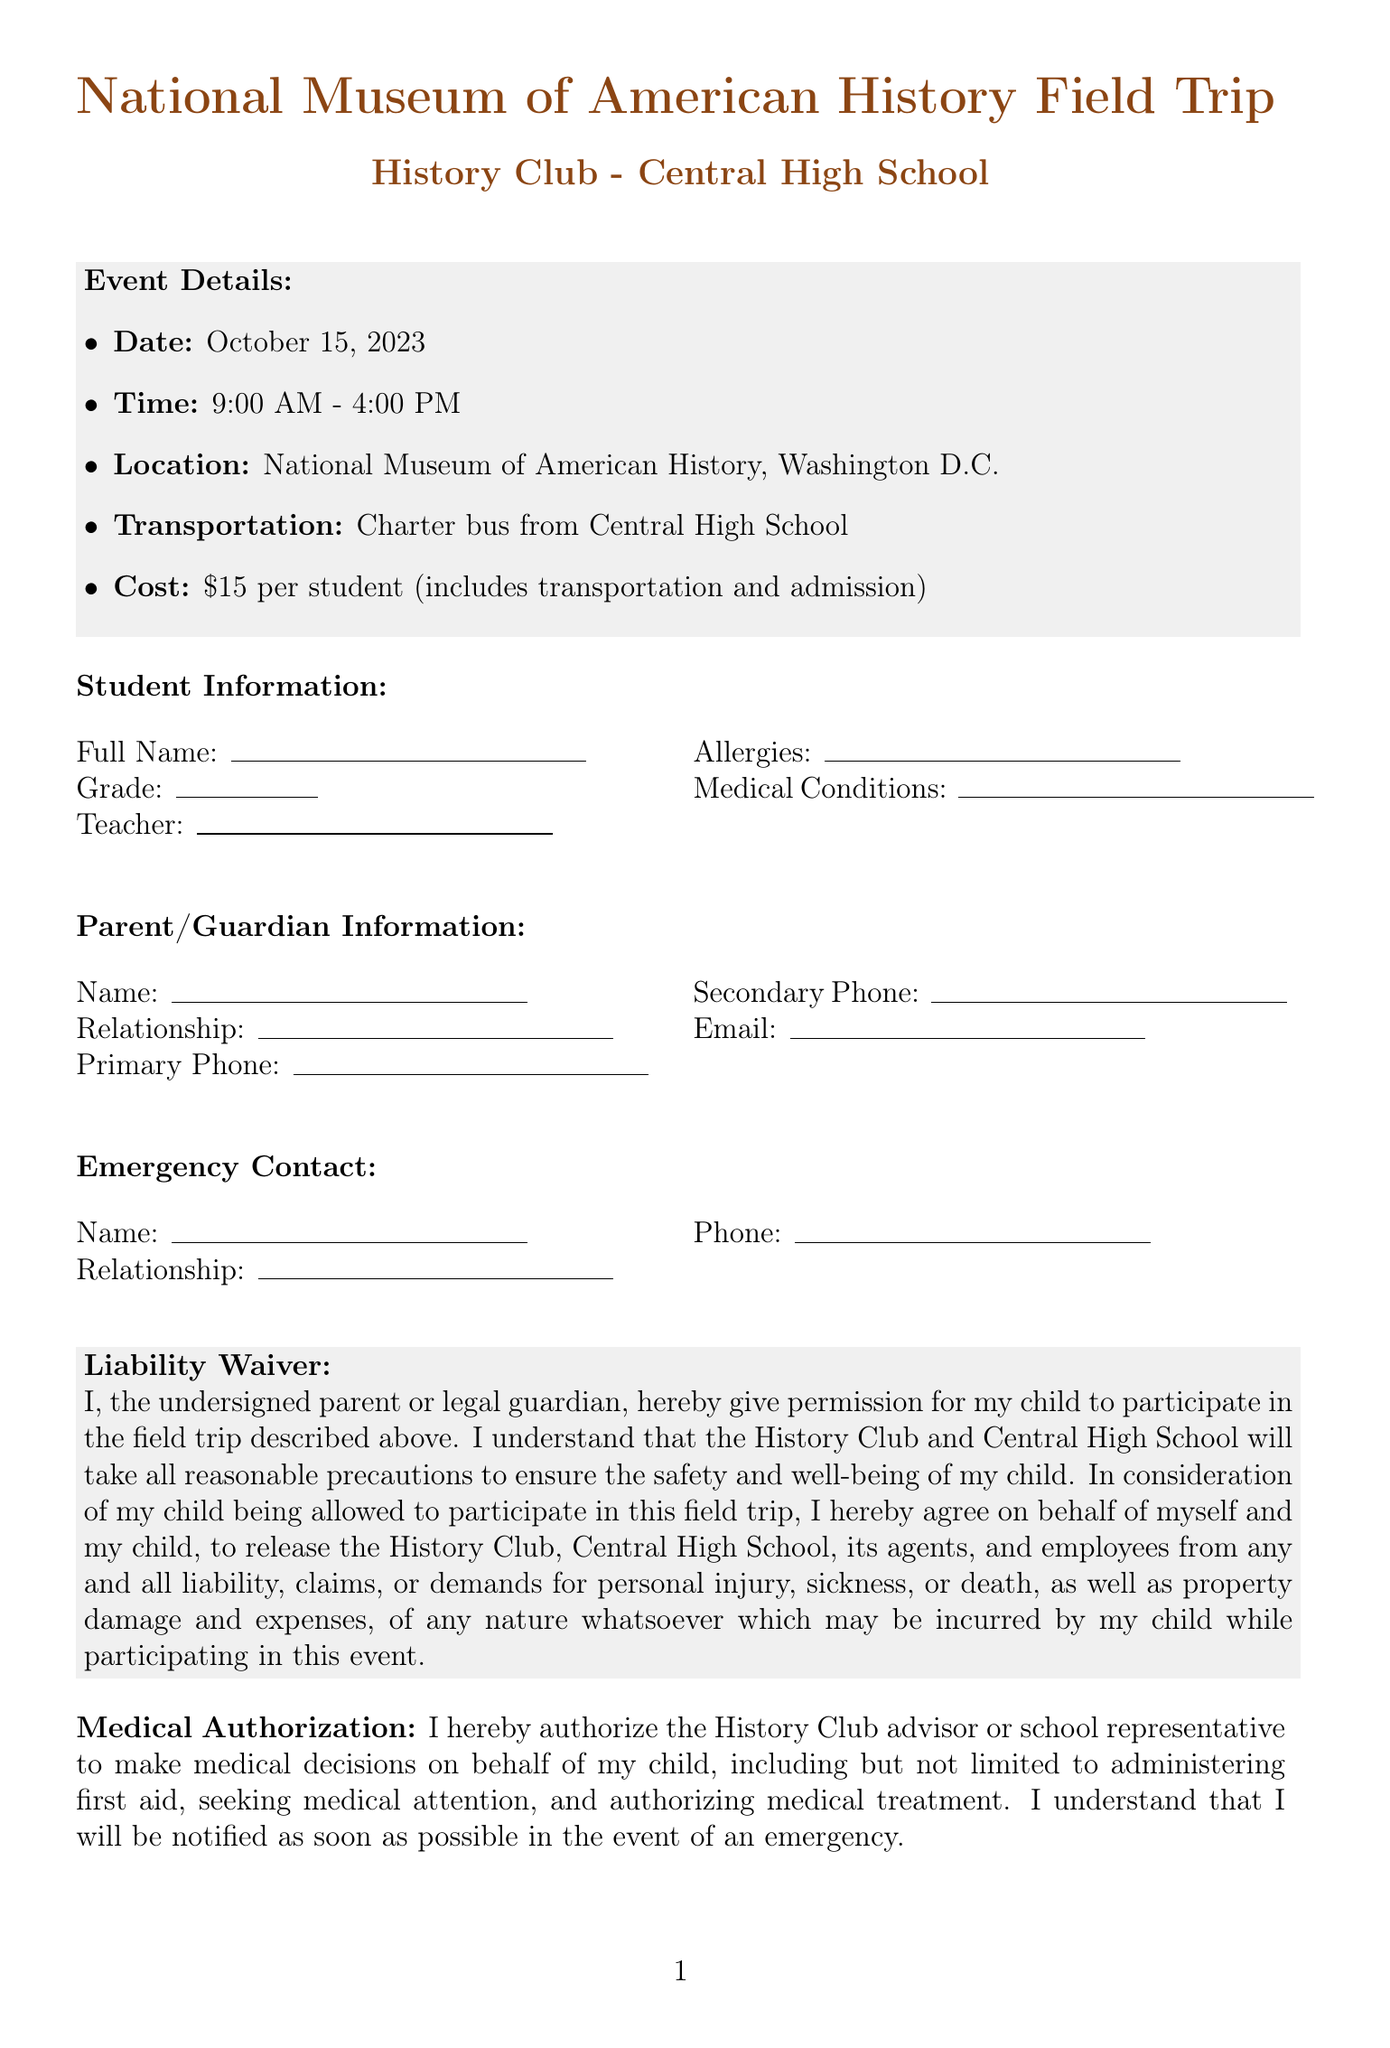What is the date of the field trip? The date of the field trip is specified in the event details section of the document.
Answer: October 15, 2023 What is the total cost per student? The total cost per student is outlined in the event details.
Answer: $15 per student Who is the lead chaperone? The lead chaperone's name is recorded in the chaperone information section of the document.
Answer: Ms. Emily Thompson What time does the bus depart? The departure time is indicated in the trip itinerary.
Answer: 9:00 AM What should students bring for lunch? The required items section mentions the suggestion regarding lunch.
Answer: Packed lunch or money for lunch What is the relationship of the emergency contact to the student? This information is usually filled out in the emergency contact section but is left blank in the document.
Answer: Not specified What medical decision authority does the History Club have? The medical authorization section explains the decisions the History Club can make in emergencies.
Answer: Make medical decisions on behalf of my child What is expected of students' behavior? The behavioral expectations section outlines the behavior consequences during the trip.
Answer: Follow all school rules What item is optional for students to bring? The required items section lists an optional item that students may bring along.
Answer: Camera 